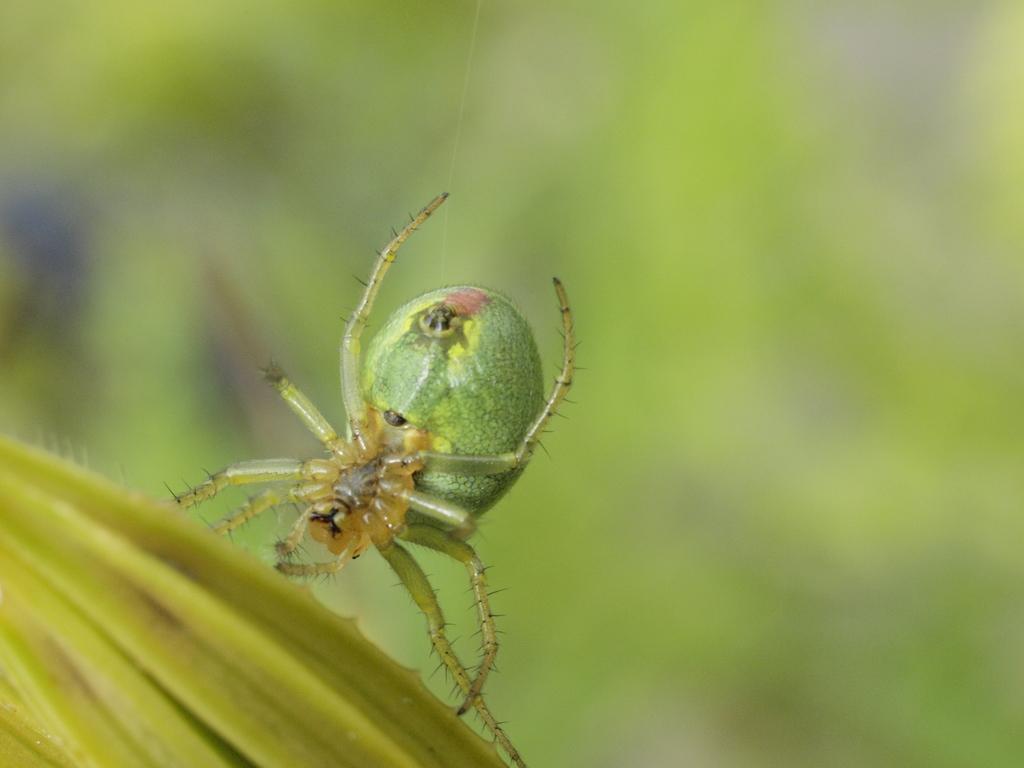How would you summarize this image in a sentence or two? There is a spider on a lemon yellow thing. In the background it is blurred. 